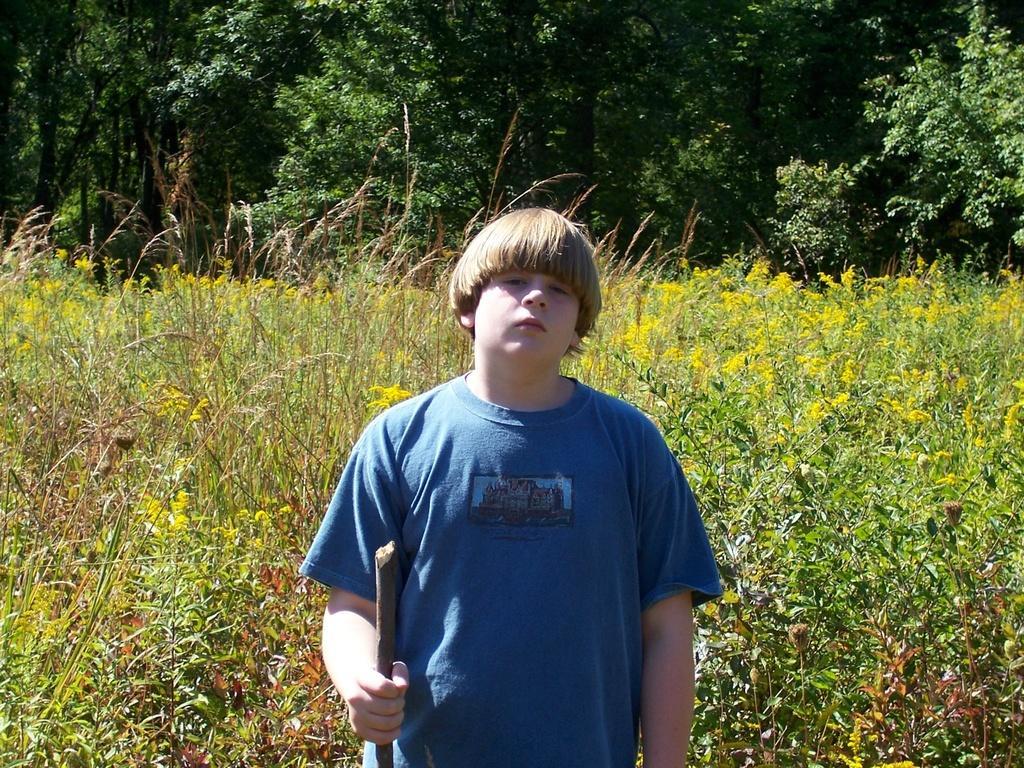How would you summarize this image in a sentence or two? In this image we can see a person holding a stick and there are few plants and trees in the background. 